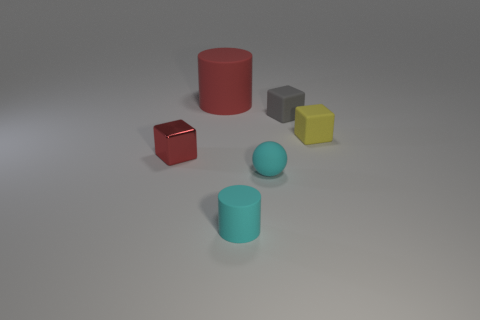There is a red thing that is in front of the big red rubber cylinder; is its shape the same as the small yellow rubber thing?
Your response must be concise. Yes. What number of things are either red cubes or big purple metal cylinders?
Offer a terse response. 1. The block that is both in front of the gray cube and on the right side of the big matte thing is made of what material?
Provide a short and direct response. Rubber. Is the size of the matte ball the same as the yellow object?
Your answer should be very brief. Yes. What size is the red object in front of the tiny object that is to the right of the gray matte thing?
Keep it short and to the point. Small. What number of rubber cylinders are both behind the tiny red shiny thing and in front of the small shiny object?
Offer a terse response. 0. Are there any cylinders on the right side of the small cyan matte thing that is behind the small cyan rubber cylinder that is on the left side of the yellow cube?
Make the answer very short. No. The shiny object that is the same size as the cyan matte sphere is what shape?
Ensure brevity in your answer.  Cube. Is there a sphere that has the same color as the small shiny cube?
Ensure brevity in your answer.  No. Is the shape of the red rubber object the same as the red metallic thing?
Offer a very short reply. No. 